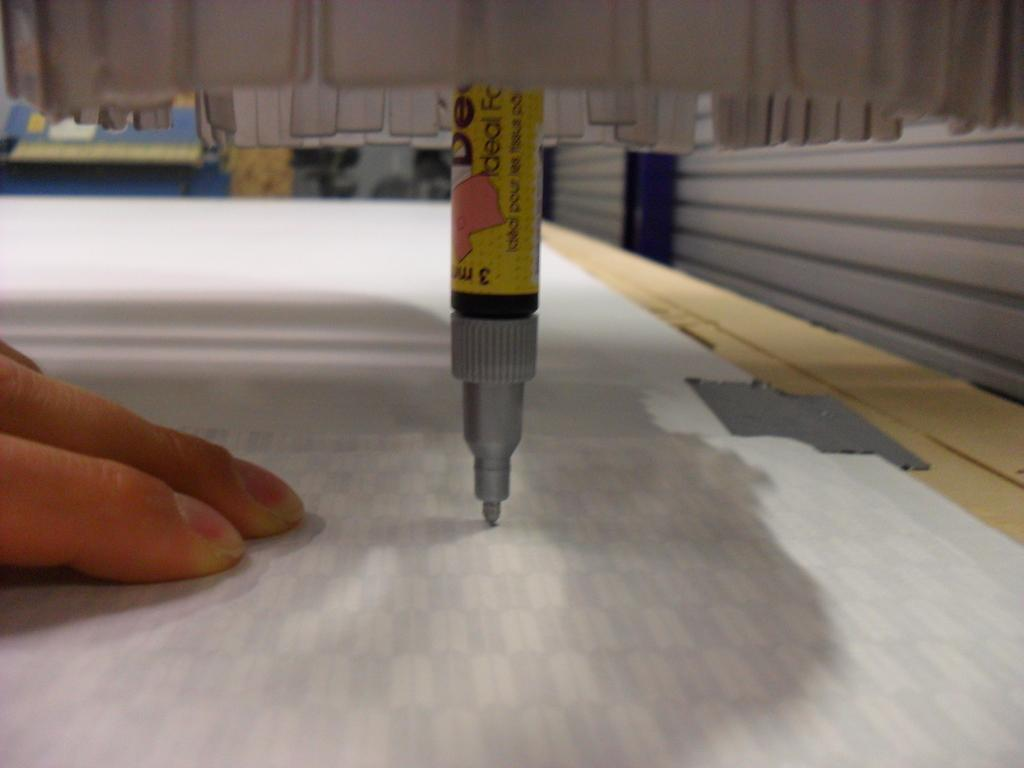<image>
Provide a brief description of the given image. A marker that says ideal on it is in position to write on a surface with a hand next to it. 